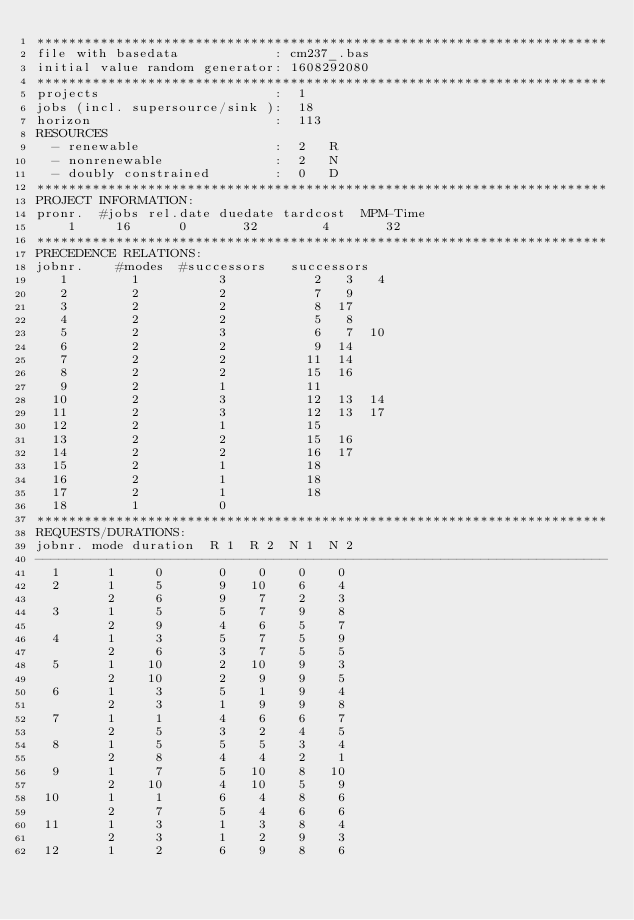<code> <loc_0><loc_0><loc_500><loc_500><_ObjectiveC_>************************************************************************
file with basedata            : cm237_.bas
initial value random generator: 1608292080
************************************************************************
projects                      :  1
jobs (incl. supersource/sink ):  18
horizon                       :  113
RESOURCES
  - renewable                 :  2   R
  - nonrenewable              :  2   N
  - doubly constrained        :  0   D
************************************************************************
PROJECT INFORMATION:
pronr.  #jobs rel.date duedate tardcost  MPM-Time
    1     16      0       32        4       32
************************************************************************
PRECEDENCE RELATIONS:
jobnr.    #modes  #successors   successors
   1        1          3           2   3   4
   2        2          2           7   9
   3        2          2           8  17
   4        2          2           5   8
   5        2          3           6   7  10
   6        2          2           9  14
   7        2          2          11  14
   8        2          2          15  16
   9        2          1          11
  10        2          3          12  13  14
  11        2          3          12  13  17
  12        2          1          15
  13        2          2          15  16
  14        2          2          16  17
  15        2          1          18
  16        2          1          18
  17        2          1          18
  18        1          0        
************************************************************************
REQUESTS/DURATIONS:
jobnr. mode duration  R 1  R 2  N 1  N 2
------------------------------------------------------------------------
  1      1     0       0    0    0    0
  2      1     5       9   10    6    4
         2     6       9    7    2    3
  3      1     5       5    7    9    8
         2     9       4    6    5    7
  4      1     3       5    7    5    9
         2     6       3    7    5    5
  5      1    10       2   10    9    3
         2    10       2    9    9    5
  6      1     3       5    1    9    4
         2     3       1    9    9    8
  7      1     1       4    6    6    7
         2     5       3    2    4    5
  8      1     5       5    5    3    4
         2     8       4    4    2    1
  9      1     7       5   10    8   10
         2    10       4   10    5    9
 10      1     1       6    4    8    6
         2     7       5    4    6    6
 11      1     3       1    3    8    4
         2     3       1    2    9    3
 12      1     2       6    9    8    6</code> 